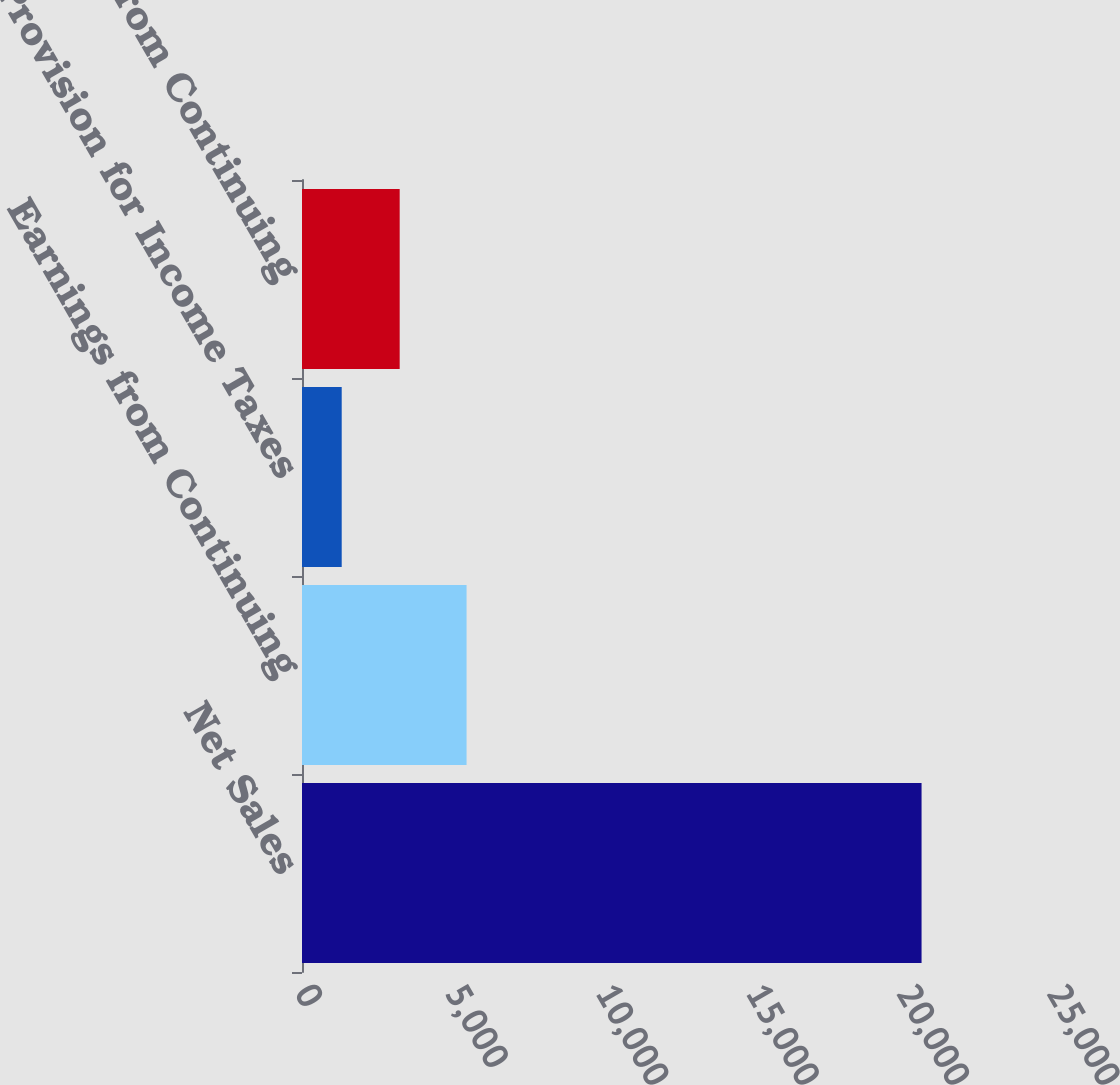Convert chart. <chart><loc_0><loc_0><loc_500><loc_500><bar_chart><fcel>Net Sales<fcel>Earnings from Continuing<fcel>Provision for Income Taxes<fcel>Net Earnings from Continuing<nl><fcel>20597<fcel>5471<fcel>1320<fcel>3247.7<nl></chart> 